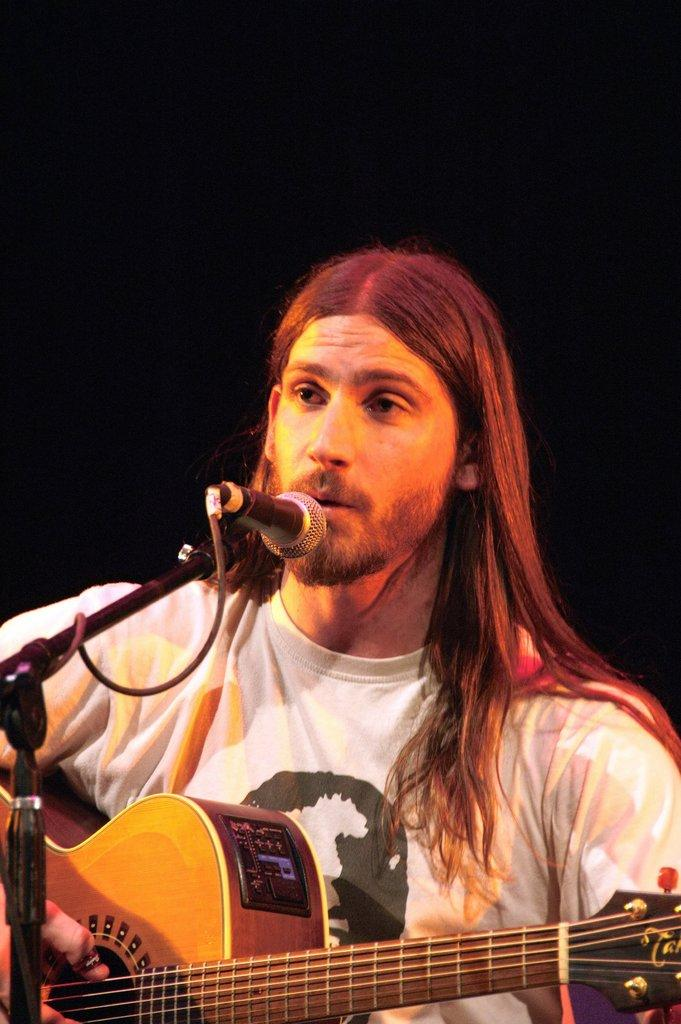What is the man in the image doing? The man is singing on a microphone. What object is the man holding in the image? The man is holding a guitar. Can you describe the man's activity in the image? The man is singing on a microphone while holding a guitar. What type of drug is the man using in the image? There is no drug present in the image; the man is singing on a microphone and holding a guitar. 